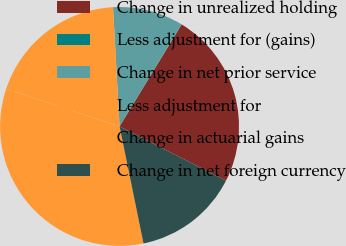Convert chart. <chart><loc_0><loc_0><loc_500><loc_500><pie_chart><fcel>Change in unrealized holding<fcel>Less adjustment for (gains)<fcel>Change in net prior service<fcel>Less adjustment for<fcel>Change in actuarial gains<fcel>Change in net foreign currency<nl><fcel>23.79%<fcel>0.04%<fcel>9.54%<fcel>19.04%<fcel>33.3%<fcel>14.29%<nl></chart> 